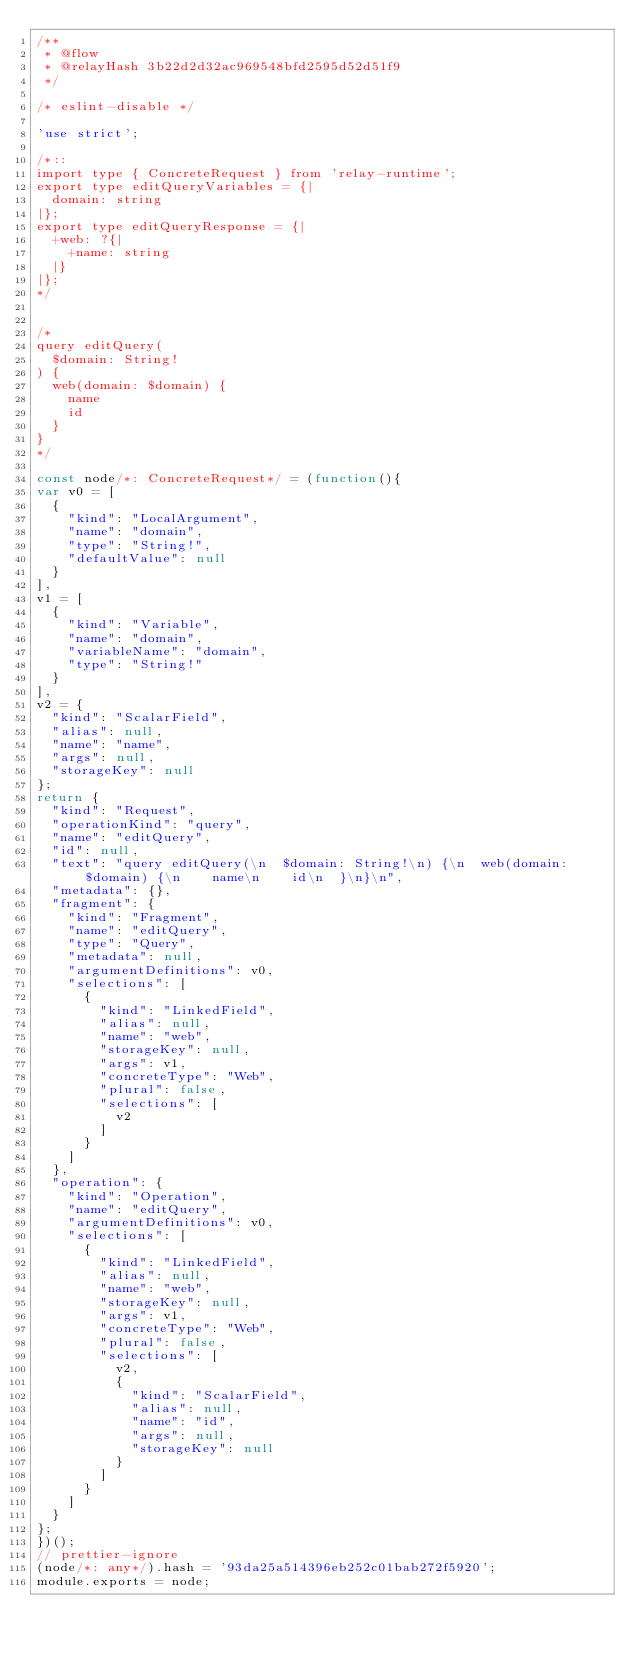<code> <loc_0><loc_0><loc_500><loc_500><_JavaScript_>/**
 * @flow
 * @relayHash 3b22d2d32ac969548bfd2595d52d51f9
 */

/* eslint-disable */

'use strict';

/*::
import type { ConcreteRequest } from 'relay-runtime';
export type editQueryVariables = {|
  domain: string
|};
export type editQueryResponse = {|
  +web: ?{|
    +name: string
  |}
|};
*/


/*
query editQuery(
  $domain: String!
) {
  web(domain: $domain) {
    name
    id
  }
}
*/

const node/*: ConcreteRequest*/ = (function(){
var v0 = [
  {
    "kind": "LocalArgument",
    "name": "domain",
    "type": "String!",
    "defaultValue": null
  }
],
v1 = [
  {
    "kind": "Variable",
    "name": "domain",
    "variableName": "domain",
    "type": "String!"
  }
],
v2 = {
  "kind": "ScalarField",
  "alias": null,
  "name": "name",
  "args": null,
  "storageKey": null
};
return {
  "kind": "Request",
  "operationKind": "query",
  "name": "editQuery",
  "id": null,
  "text": "query editQuery(\n  $domain: String!\n) {\n  web(domain: $domain) {\n    name\n    id\n  }\n}\n",
  "metadata": {},
  "fragment": {
    "kind": "Fragment",
    "name": "editQuery",
    "type": "Query",
    "metadata": null,
    "argumentDefinitions": v0,
    "selections": [
      {
        "kind": "LinkedField",
        "alias": null,
        "name": "web",
        "storageKey": null,
        "args": v1,
        "concreteType": "Web",
        "plural": false,
        "selections": [
          v2
        ]
      }
    ]
  },
  "operation": {
    "kind": "Operation",
    "name": "editQuery",
    "argumentDefinitions": v0,
    "selections": [
      {
        "kind": "LinkedField",
        "alias": null,
        "name": "web",
        "storageKey": null,
        "args": v1,
        "concreteType": "Web",
        "plural": false,
        "selections": [
          v2,
          {
            "kind": "ScalarField",
            "alias": null,
            "name": "id",
            "args": null,
            "storageKey": null
          }
        ]
      }
    ]
  }
};
})();
// prettier-ignore
(node/*: any*/).hash = '93da25a514396eb252c01bab272f5920';
module.exports = node;
</code> 